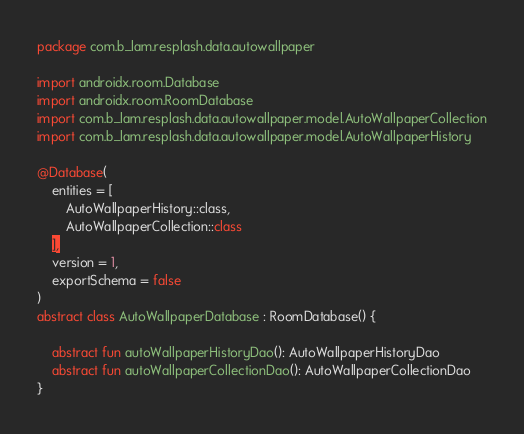Convert code to text. <code><loc_0><loc_0><loc_500><loc_500><_Kotlin_>package com.b_lam.resplash.data.autowallpaper

import androidx.room.Database
import androidx.room.RoomDatabase
import com.b_lam.resplash.data.autowallpaper.model.AutoWallpaperCollection
import com.b_lam.resplash.data.autowallpaper.model.AutoWallpaperHistory

@Database(
    entities = [
        AutoWallpaperHistory::class,
        AutoWallpaperCollection::class
    ],
    version = 1,
    exportSchema = false
)
abstract class AutoWallpaperDatabase : RoomDatabase() {

    abstract fun autoWallpaperHistoryDao(): AutoWallpaperHistoryDao
    abstract fun autoWallpaperCollectionDao(): AutoWallpaperCollectionDao
}</code> 